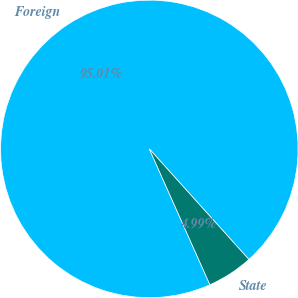Convert chart to OTSL. <chart><loc_0><loc_0><loc_500><loc_500><pie_chart><fcel>Foreign<fcel>State<nl><fcel>95.01%<fcel>4.99%<nl></chart> 